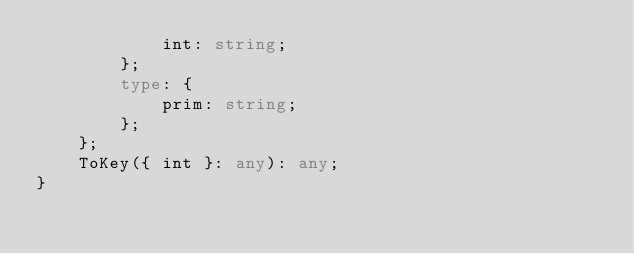Convert code to text. <code><loc_0><loc_0><loc_500><loc_500><_TypeScript_>            int: string;
        };
        type: {
            prim: string;
        };
    };
    ToKey({ int }: any): any;
}
</code> 